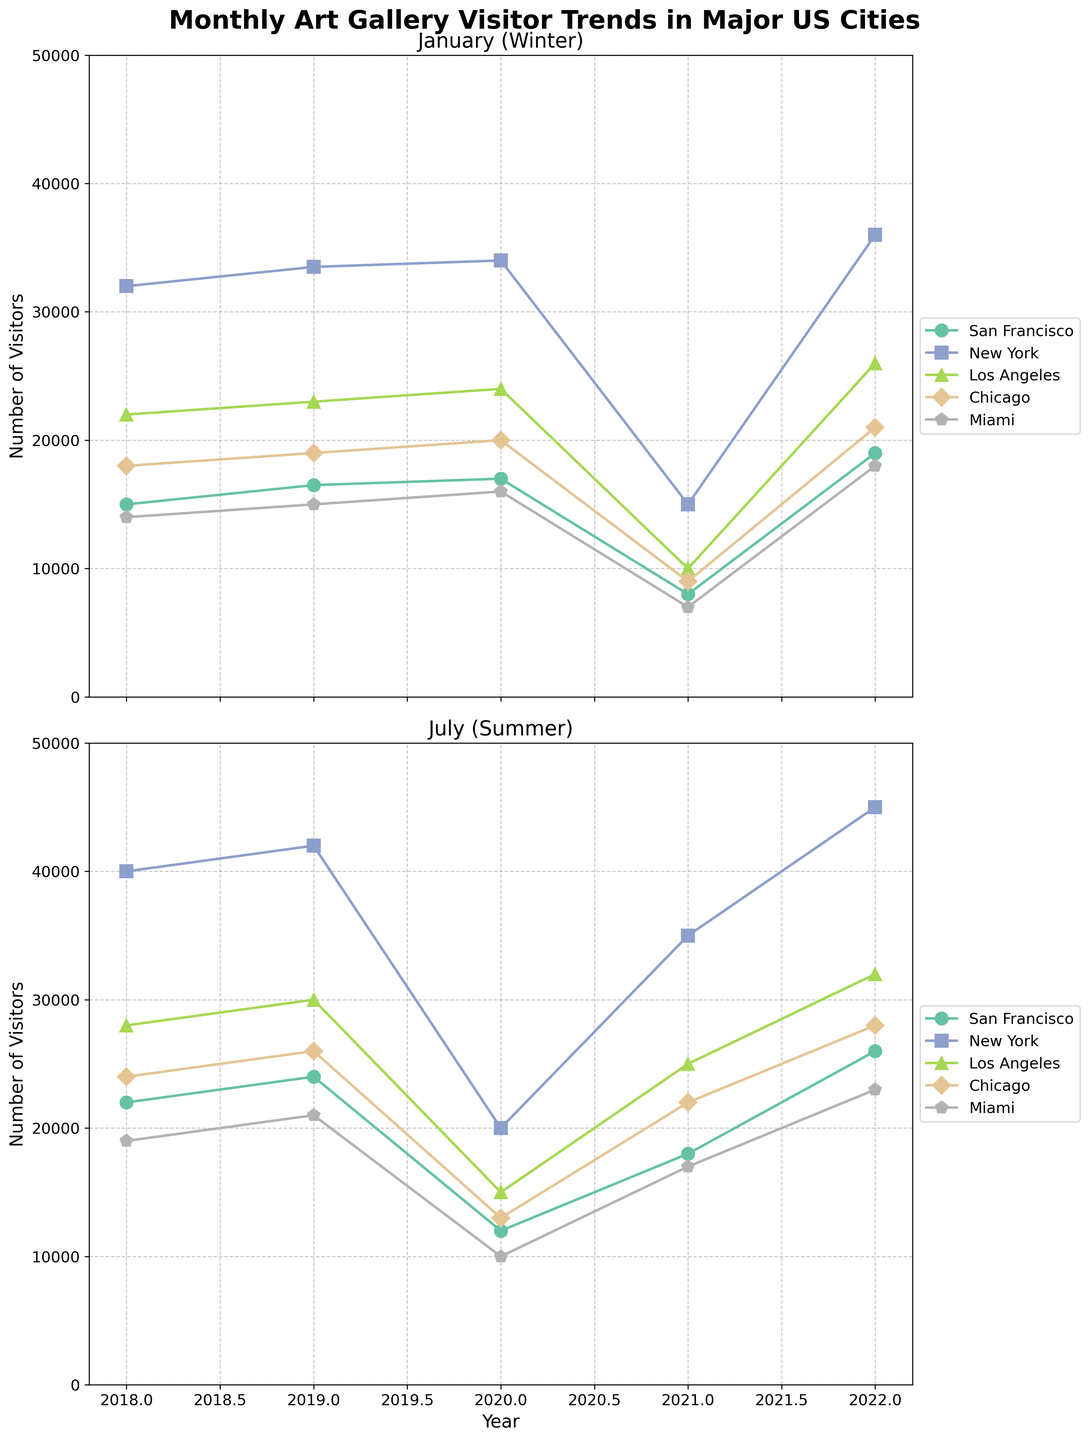What is the title of the figure? The title is visually placed at the top of the figure and describes the content of the plots. The title reads "Monthly Art Gallery Visitor Trends in Major US Cities".
Answer: Monthly Art Gallery Visitor Trends in Major US Cities Which city had the highest number of visitors in July 2022? By examining the summer subplot (July), we look at the data points for July 2022. New York has the highest value among the cities.
Answer: New York How did the number of visitors in San Francisco change from January 2020 to January 2021? In the winter subplot (January), find the points for San Francisco in January 2020 and January 2021. The number of visitors decreased from 17,000 to 8,000.
Answer: Decreased Which city reported the lowest number of visitors in January 2021? In the winter subplot (January), find the points for January 2021 and identify the city with the smallest value. Miami has the lowest value of 7,000 visitors.
Answer: Miami What is the difference in the number of visitors between July 2018 and July 2020 for Los Angeles? On the summer subplot (July), find the values for Los Angeles in July 2018 (28,000) and July 2020 (15,000). The difference is 28,000 - 15,000 = 13,000.
Answer: 13,000 Did Chicago experience a higher visitor count in January 2019 or July 2019? Compare the two data points for Chicago in January 2019 and July 2019 in their respective subplots. January 2019 had 19,000 visitors, and July 2019 had 26,000 visitors.
Answer: July 2019 Which city saw a recovery in visitor numbers from July 2020 to July 2021? Examine the summer subplot (July) to compare the numbers from July 2020 to July 2021. Multiple cities show recovery, but focus on San Francisco which increased from 12,000 to 18,000.
Answer: San Francisco What trend is observable for New York’s summer visitor numbers across the years plotted? By examining the summer data line for New York, we observe that it generally increases from 2018 through 2022, except for the dip in 2020.
Answer: Increase with a dip in 2020 Based on the subplots, which month typically had higher visitor numbers, January or July? By comparing equivalent points across both subplots for January and July from 2018 to 2022, July consistently has higher visitor numbers than January in all cities.
Answer: July Did any city have a higher visitor count in January 2022 than in July 2021? Compare the values for January 2022 with those of July 2021 across all cities in the respective subplots. While most cities have higher counts in July, some cities have increased or comparable numbers in both months. New York for instance continues its upward trend across both periods.
Answer: No 